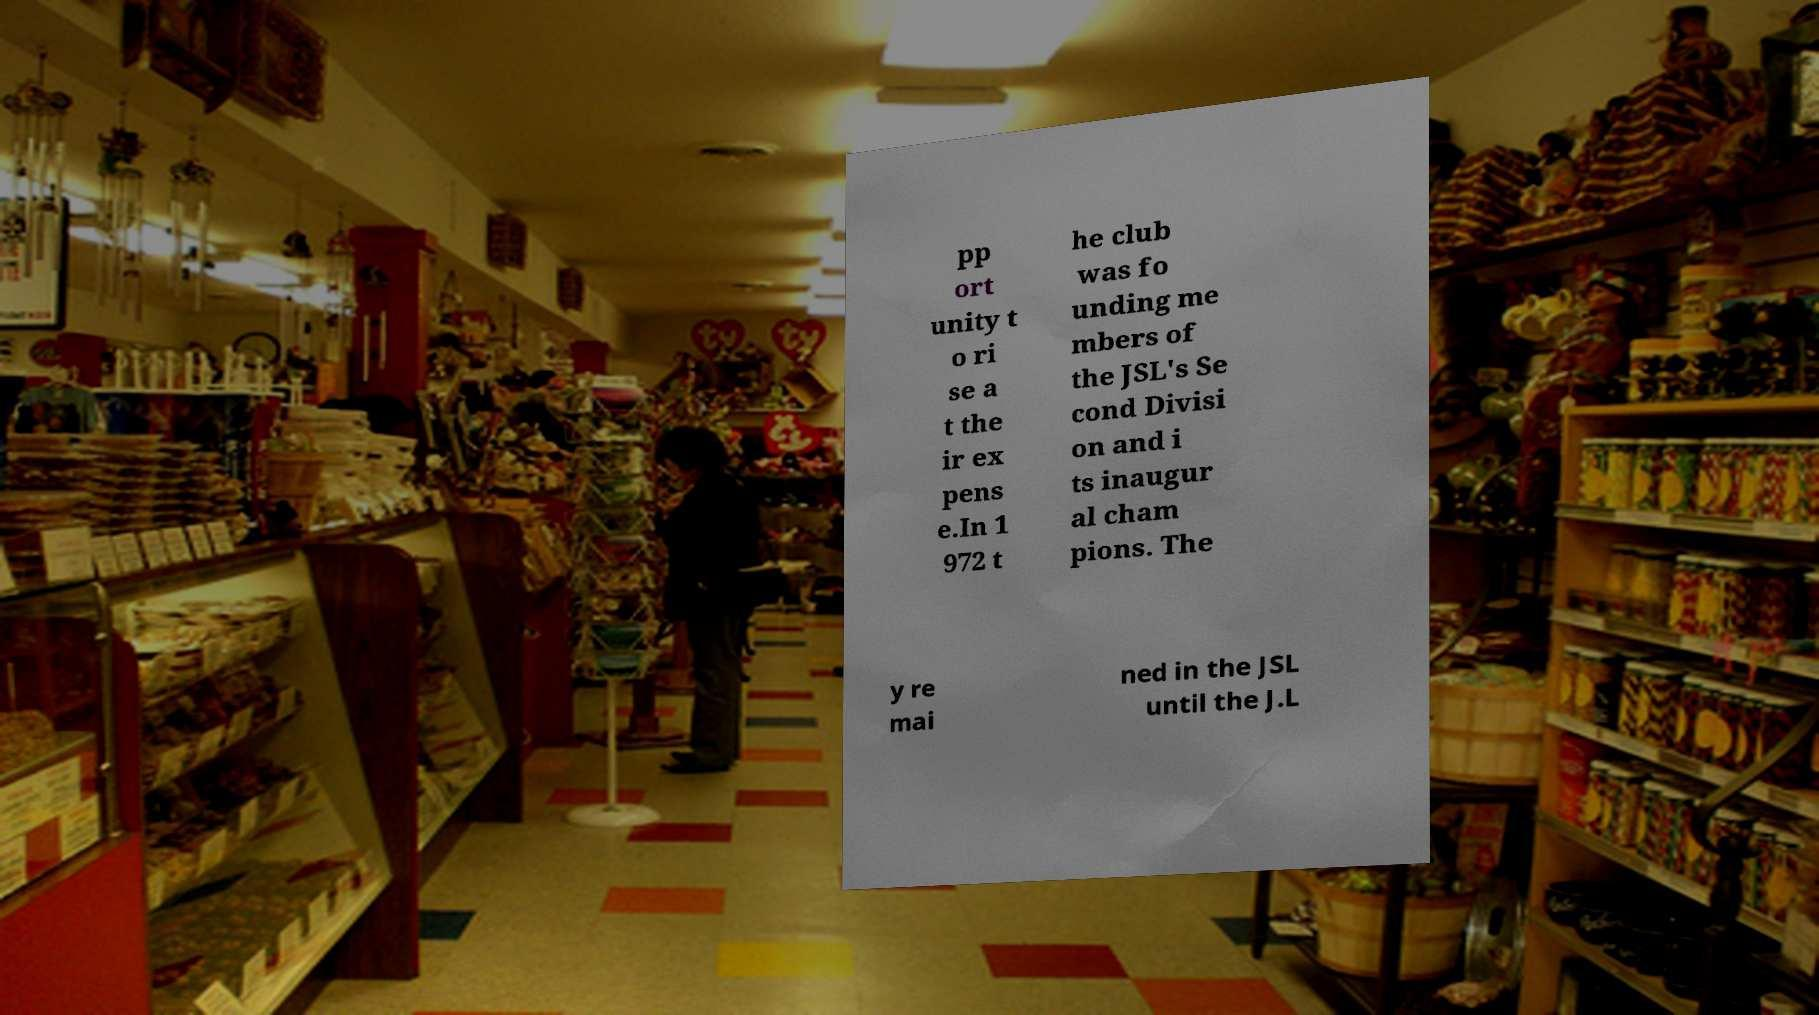Could you assist in decoding the text presented in this image and type it out clearly? pp ort unity t o ri se a t the ir ex pens e.In 1 972 t he club was fo unding me mbers of the JSL's Se cond Divisi on and i ts inaugur al cham pions. The y re mai ned in the JSL until the J.L 